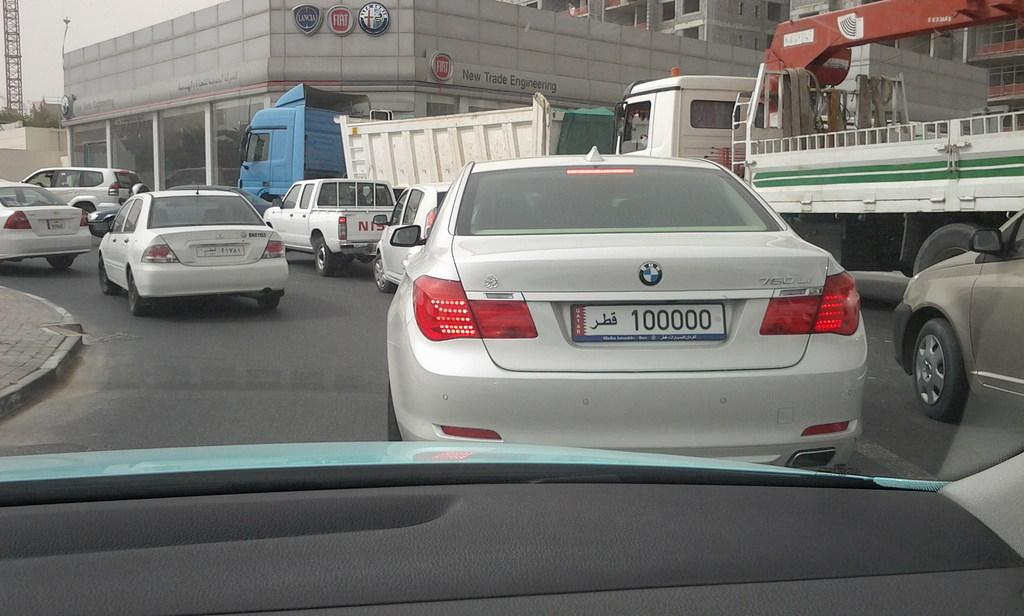<image>
Give a short and clear explanation of the subsequent image. Cars are seen through a windshield, including a BMW 750 Li. 